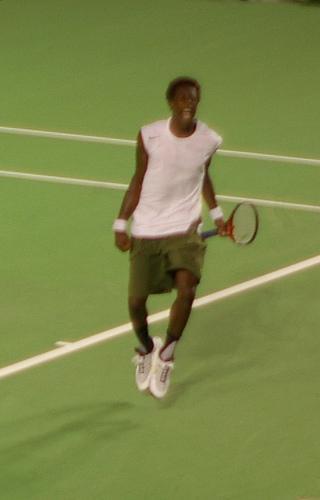How many courts can be seen?
Give a very brief answer. 1. 